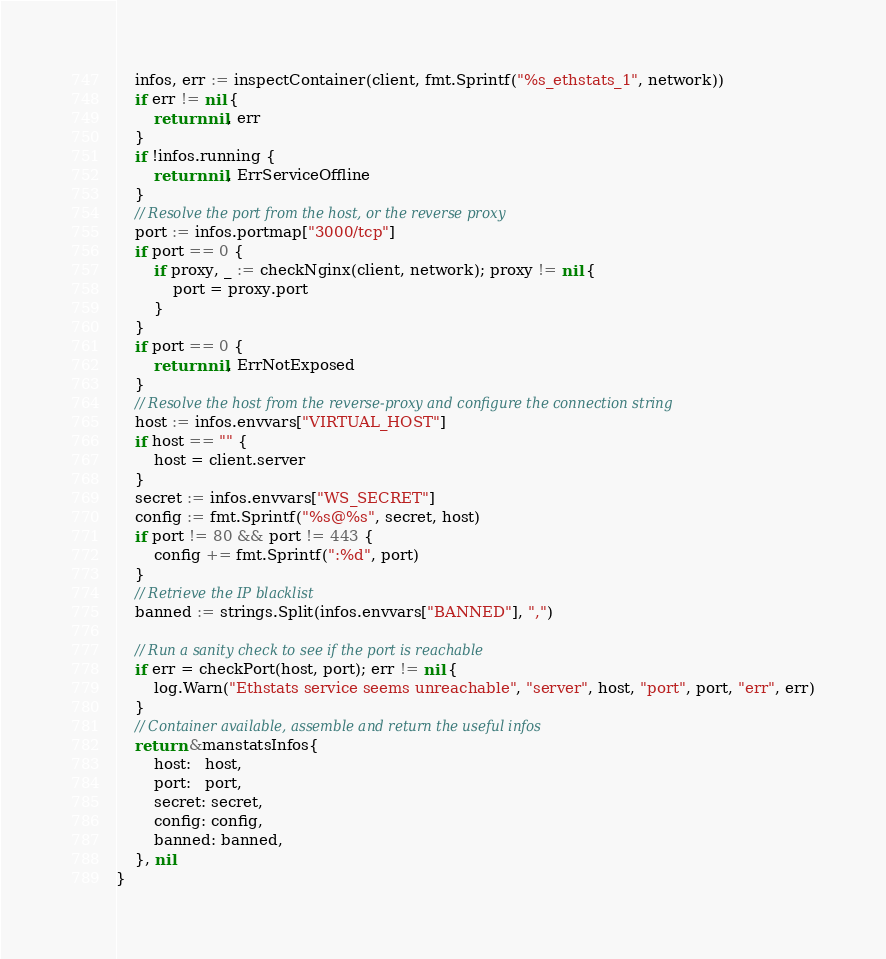Convert code to text. <code><loc_0><loc_0><loc_500><loc_500><_Go_>	infos, err := inspectContainer(client, fmt.Sprintf("%s_ethstats_1", network))
	if err != nil {
		return nil, err
	}
	if !infos.running {
		return nil, ErrServiceOffline
	}
	// Resolve the port from the host, or the reverse proxy
	port := infos.portmap["3000/tcp"]
	if port == 0 {
		if proxy, _ := checkNginx(client, network); proxy != nil {
			port = proxy.port
		}
	}
	if port == 0 {
		return nil, ErrNotExposed
	}
	// Resolve the host from the reverse-proxy and configure the connection string
	host := infos.envvars["VIRTUAL_HOST"]
	if host == "" {
		host = client.server
	}
	secret := infos.envvars["WS_SECRET"]
	config := fmt.Sprintf("%s@%s", secret, host)
	if port != 80 && port != 443 {
		config += fmt.Sprintf(":%d", port)
	}
	// Retrieve the IP blacklist
	banned := strings.Split(infos.envvars["BANNED"], ",")

	// Run a sanity check to see if the port is reachable
	if err = checkPort(host, port); err != nil {
		log.Warn("Ethstats service seems unreachable", "server", host, "port", port, "err", err)
	}
	// Container available, assemble and return the useful infos
	return &manstatsInfos{
		host:   host,
		port:   port,
		secret: secret,
		config: config,
		banned: banned,
	}, nil
}
</code> 